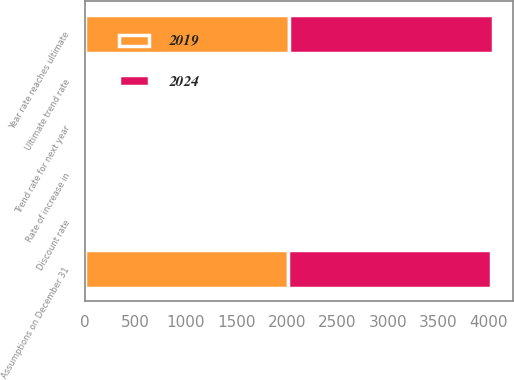Convert chart. <chart><loc_0><loc_0><loc_500><loc_500><stacked_bar_chart><ecel><fcel>Assumptions on December 31<fcel>Discount rate<fcel>Rate of increase in<fcel>Trend rate for next year<fcel>Ultimate trend rate<fcel>Year rate reaches ultimate<nl><fcel>2024<fcel>2014<fcel>4.1<fcel>3.43<fcel>7<fcel>5<fcel>2024<nl><fcel>2019<fcel>2013<fcel>4.95<fcel>3.7<fcel>8<fcel>5<fcel>2019<nl></chart> 